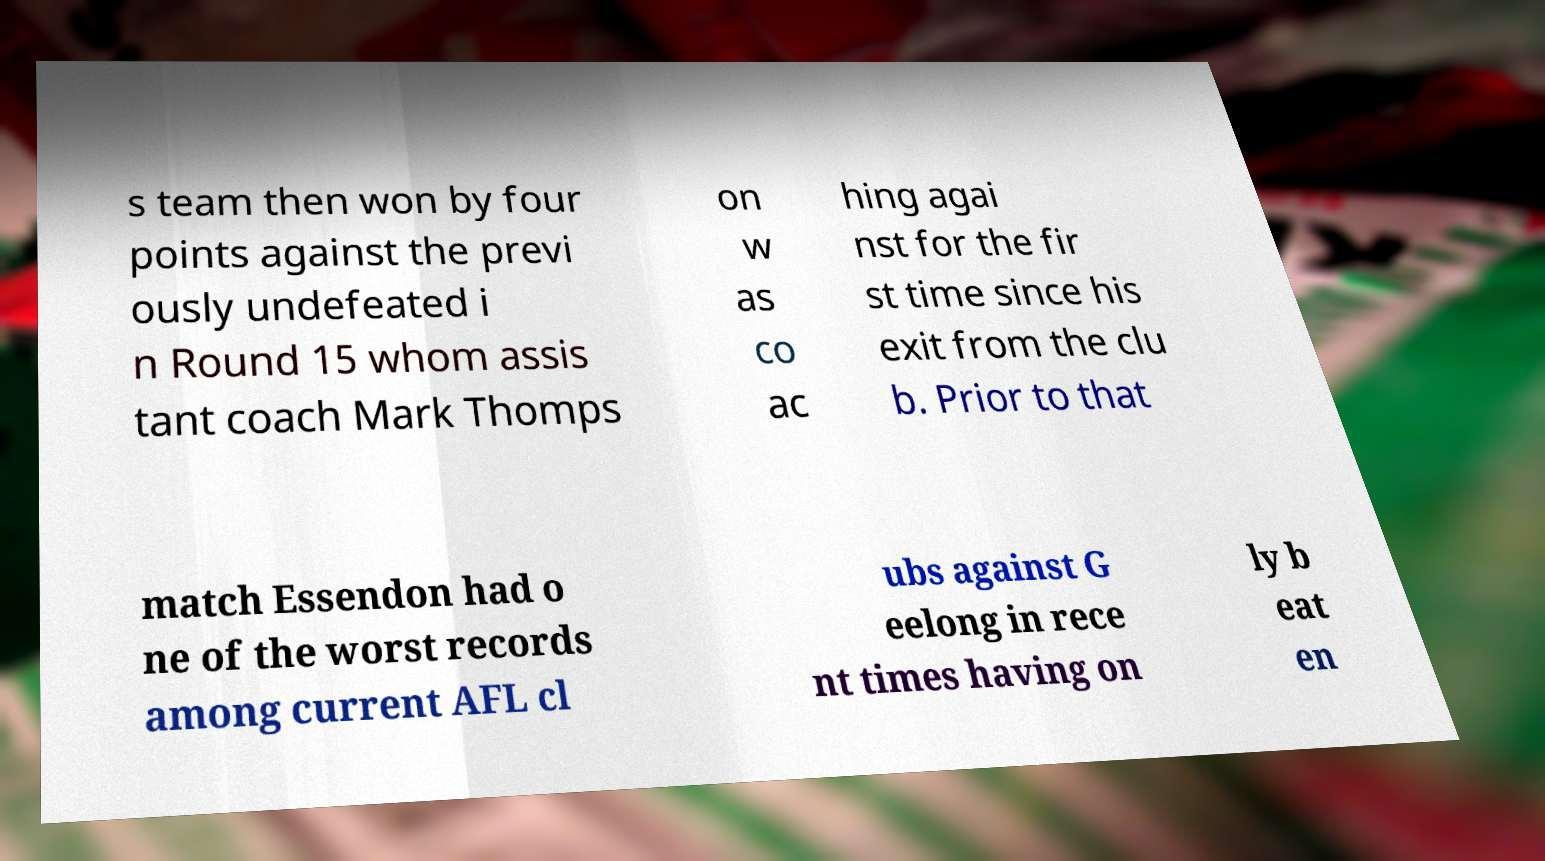For documentation purposes, I need the text within this image transcribed. Could you provide that? s team then won by four points against the previ ously undefeated i n Round 15 whom assis tant coach Mark Thomps on w as co ac hing agai nst for the fir st time since his exit from the clu b. Prior to that match Essendon had o ne of the worst records among current AFL cl ubs against G eelong in rece nt times having on ly b eat en 